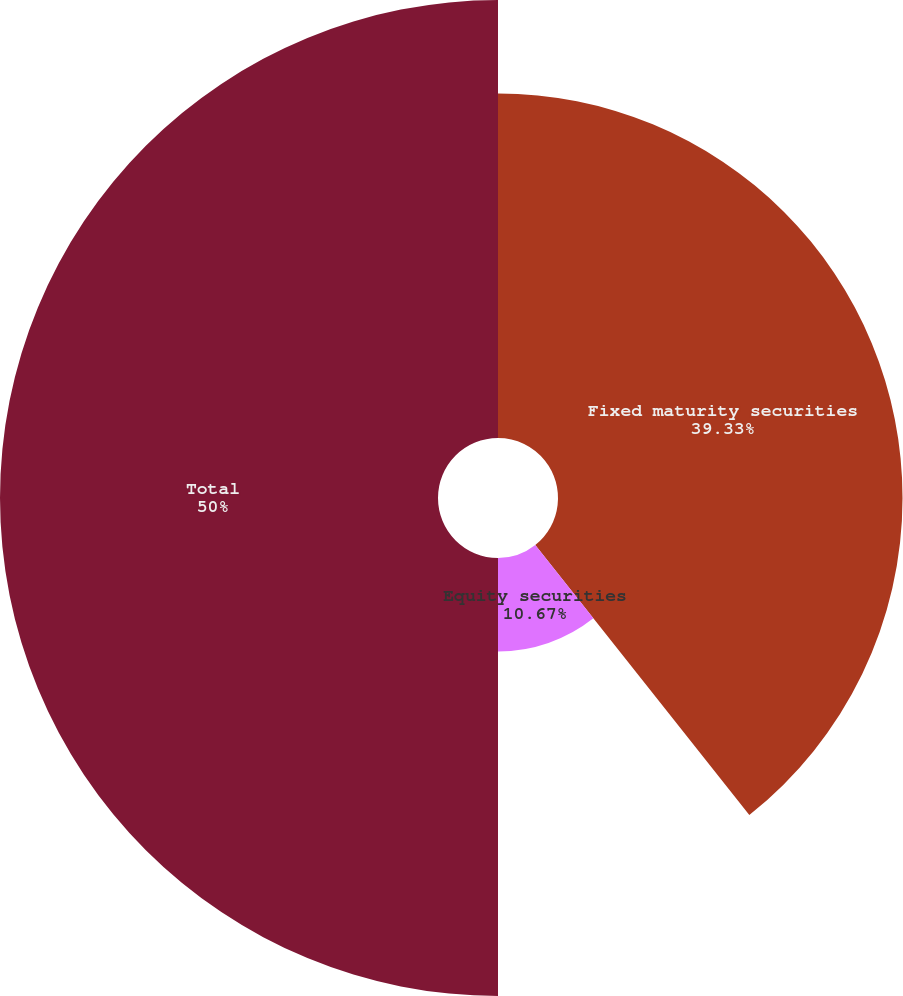<chart> <loc_0><loc_0><loc_500><loc_500><pie_chart><fcel>Fixed maturity securities<fcel>Equity securities<fcel>Total<nl><fcel>39.33%<fcel>10.67%<fcel>50.0%<nl></chart> 